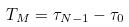Convert formula to latex. <formula><loc_0><loc_0><loc_500><loc_500>T _ { M } = \tau _ { N - 1 } - \tau _ { 0 }</formula> 